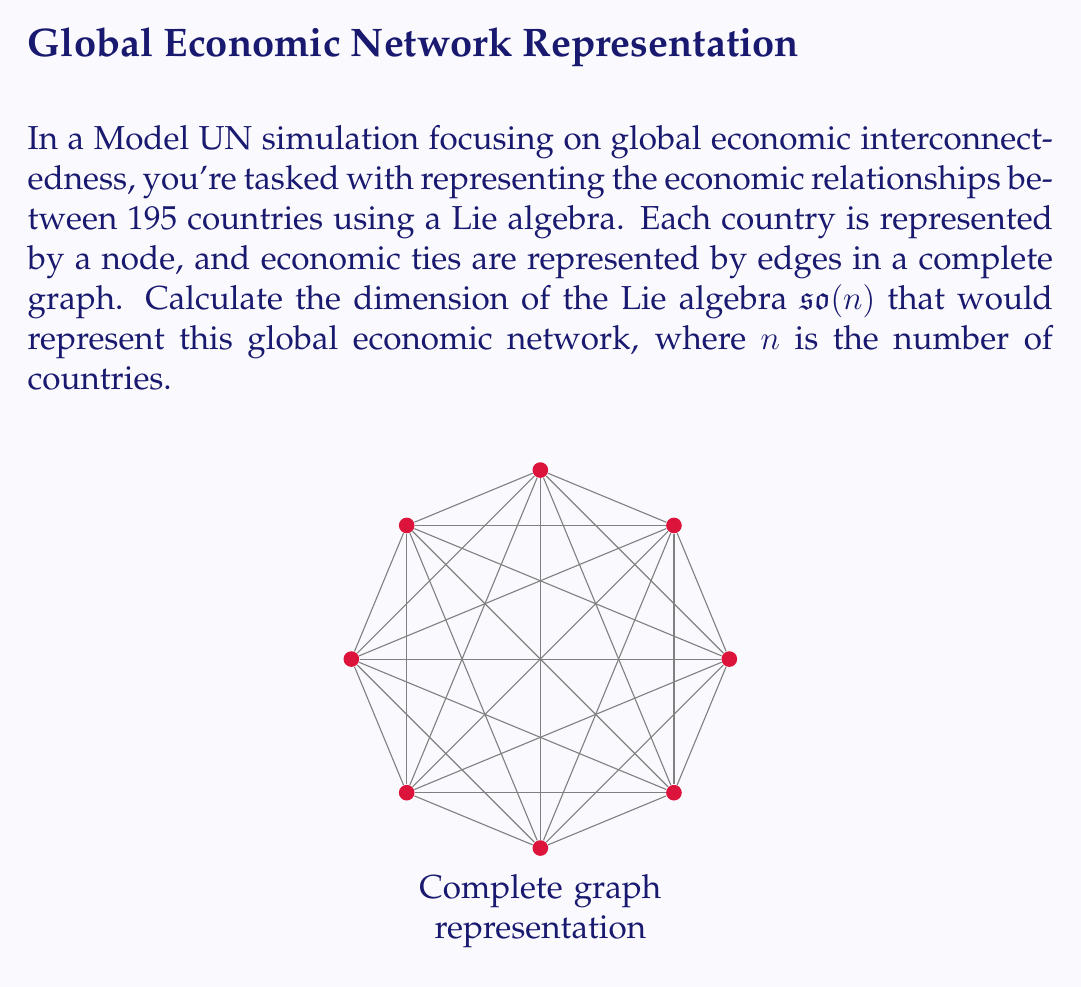Help me with this question. To solve this problem, we'll follow these steps:

1) First, recall that for a Lie algebra $\mathfrak{so}(n)$, which represents the special orthogonal group $SO(n)$, the dimension is given by:

   $$\dim(\mathfrak{so}(n)) = \frac{n(n-1)}{2}$$

2) In our case, $n$ represents the number of countries, which is 195.

3) Let's substitute this into our formula:

   $$\dim(\mathfrak{so}(195)) = \frac{195(195-1)}{2}$$

4) Simplify:
   $$\dim(\mathfrak{so}(195)) = \frac{195(194)}{2}$$

5) Multiply:
   $$\dim(\mathfrak{so}(195)) = \frac{37830}{2}$$

6) Divide:
   $$\dim(\mathfrak{so}(195)) = 18915$$

Therefore, the dimension of the Lie algebra representing the global economic interconnectedness of 195 countries is 18,915.
Answer: 18,915 